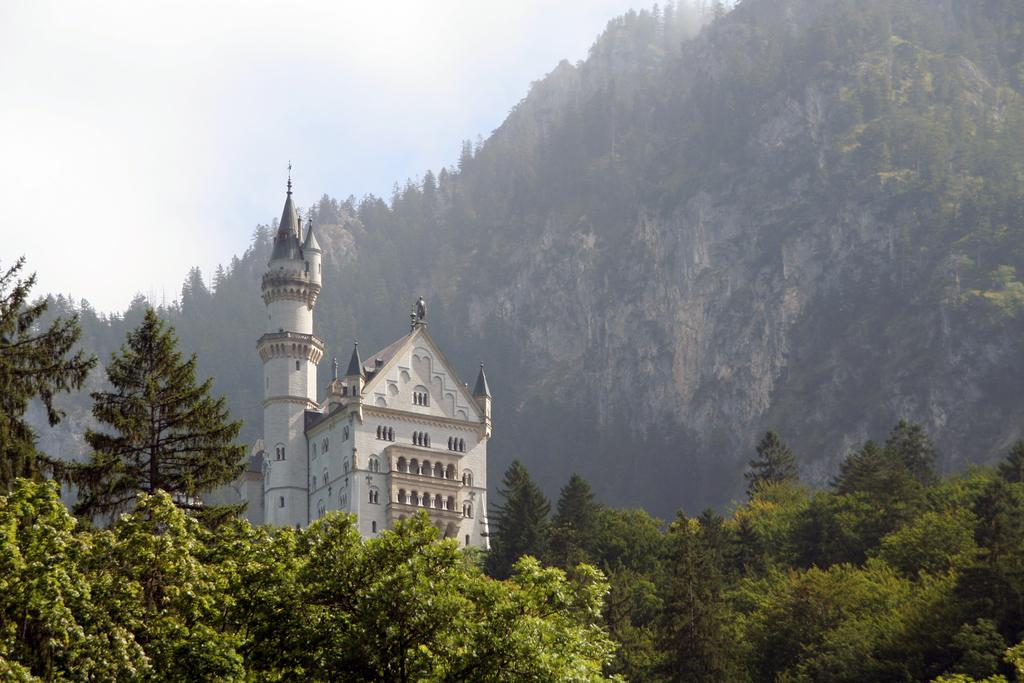What type of structure is present in the image? There is a building in the image. What natural elements can be seen in the image? There is a group of trees and hills visible in the image. What is visible in the background of the image? The sky is visible in the image. How would you describe the sky in the image? The sky appears cloudy in the image. Can you see a tiger hiding behind the trees in the image? No, there is no tiger present in the image. 